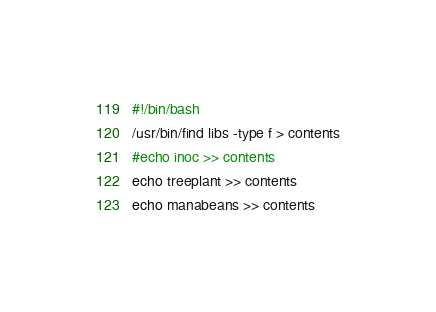<code> <loc_0><loc_0><loc_500><loc_500><_Bash_>#!/bin/bash
/usr/bin/find libs -type f > contents
#echo inoc >> contents
echo treeplant >> contents
echo manabeans >> contents
</code> 